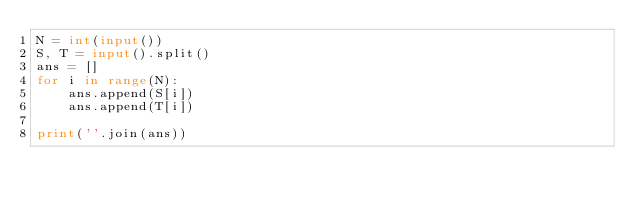Convert code to text. <code><loc_0><loc_0><loc_500><loc_500><_Python_>N = int(input())
S, T = input().split()
ans = []
for i in range(N):
    ans.append(S[i])
    ans.append(T[i])

print(''.join(ans))</code> 